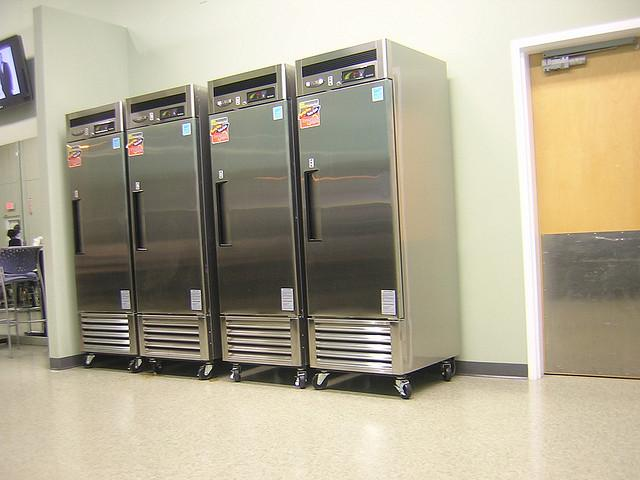Where is this scene taking place? Please explain your reasoning. cafeteria. You can tell by the roll-away coolers as to where this is. 